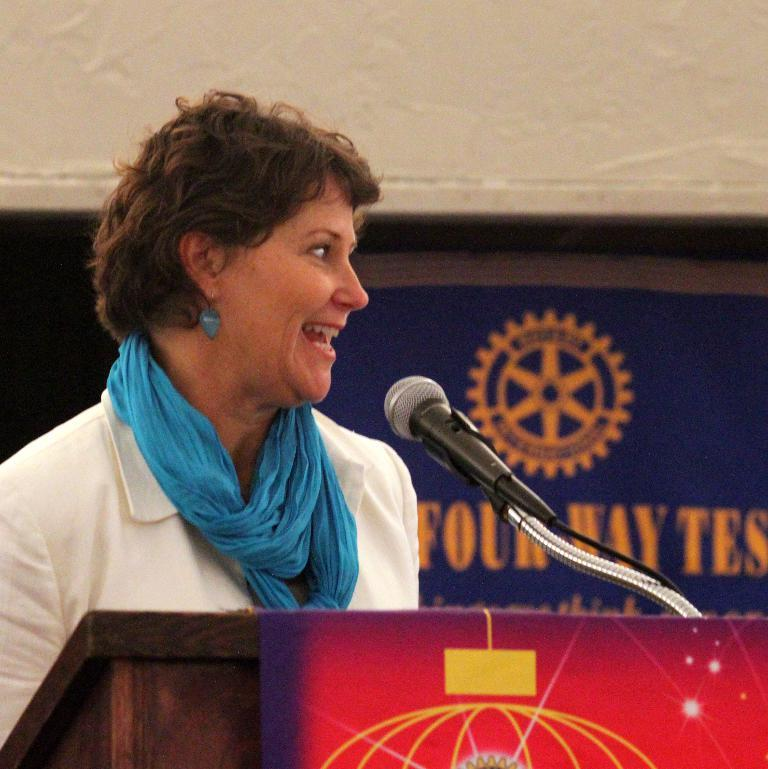Who is the main subject in the image? There is a woman in the image. What is the woman wearing? The woman is wearing a white suit. What is the woman doing in the image? The woman is standing at a speech desk. What is the woman's facial expression? The woman is smiling. What direction is the woman looking? The woman is looking to the right side. What color is the banner in the background? There is a blue color banner in the background. How many rings is the woman wearing on her left hand in the image? There is no mention of rings in the image, so we cannot determine how many rings the woman is wearing. 